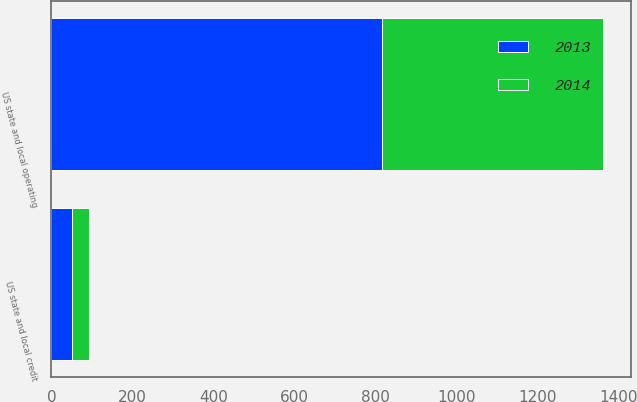Convert chart. <chart><loc_0><loc_0><loc_500><loc_500><stacked_bar_chart><ecel><fcel>US state and local operating<fcel>US state and local credit<nl><fcel>2013<fcel>815<fcel>52<nl><fcel>2014<fcel>546<fcel>42<nl></chart> 